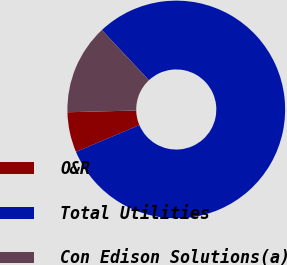Convert chart. <chart><loc_0><loc_0><loc_500><loc_500><pie_chart><fcel>O&R<fcel>Total Utilities<fcel>Con Edison Solutions(a)<nl><fcel>5.96%<fcel>80.61%<fcel>13.43%<nl></chart> 